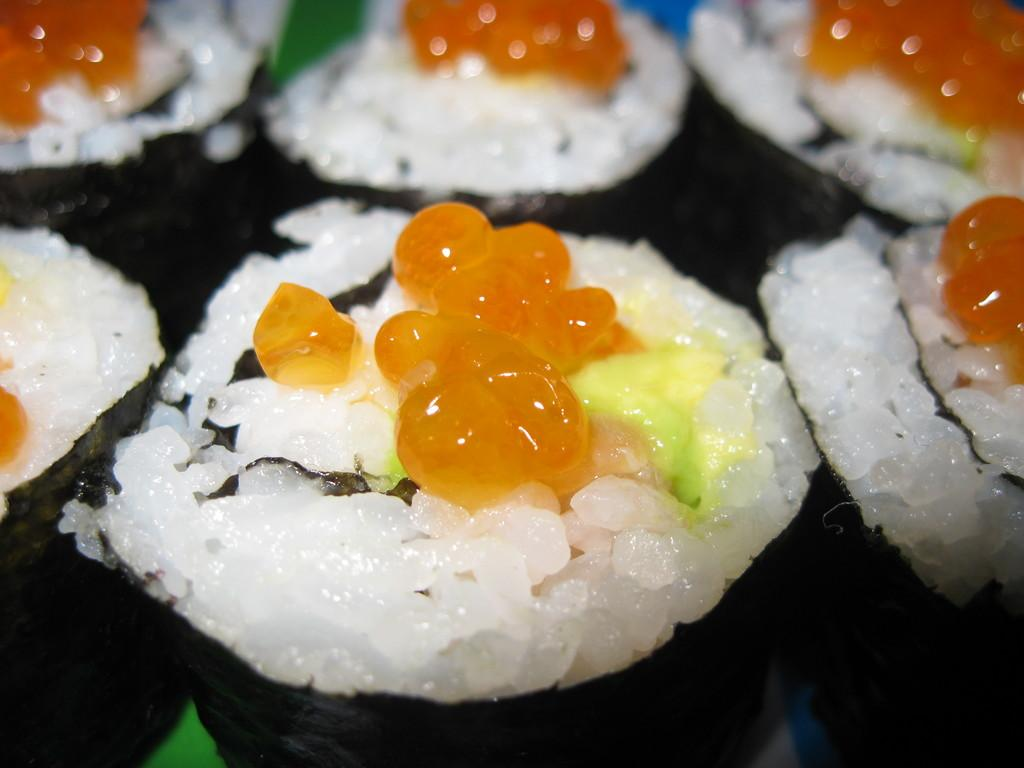What type of food is visible in the image? There is sushi in the image. How many sisters are present in the image? There are no sisters present in the image, as it only features sushi. What type of beast can be seen interacting with the sushi in the image? There is no beast present in the image, and the sushi is not interacting with any creature. 